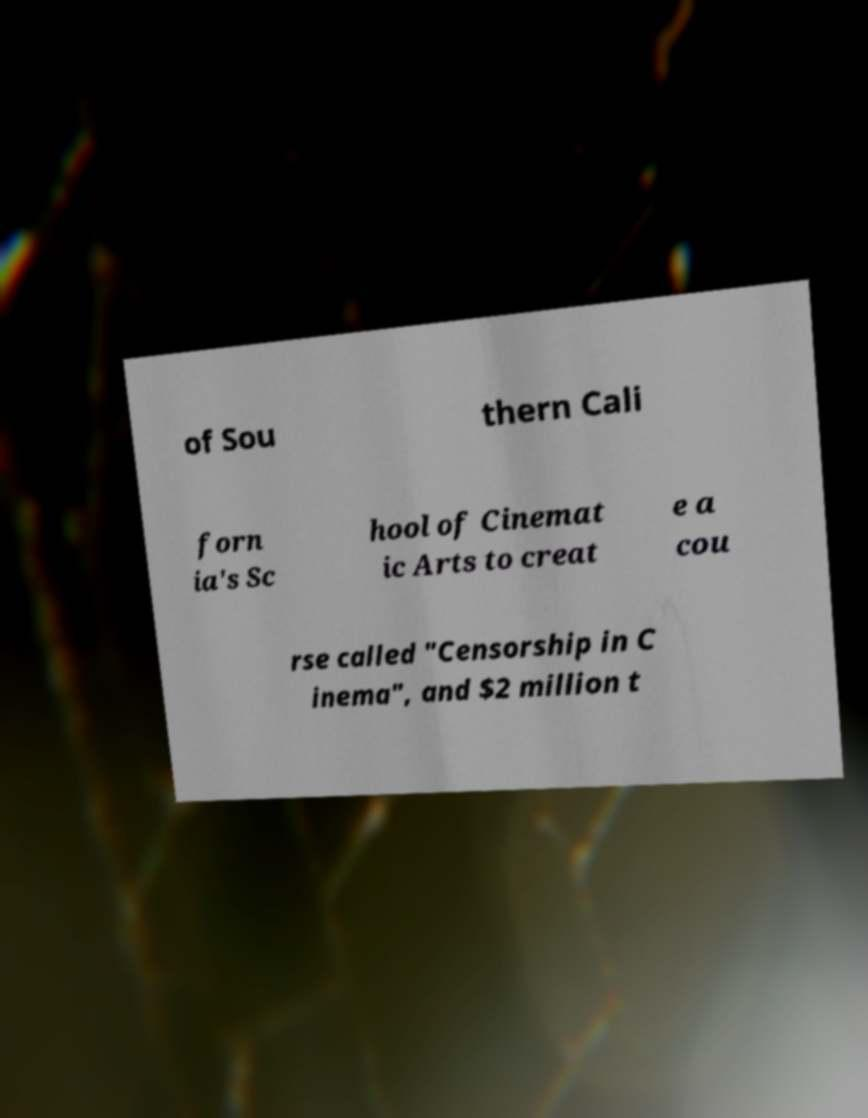Could you assist in decoding the text presented in this image and type it out clearly? of Sou thern Cali forn ia's Sc hool of Cinemat ic Arts to creat e a cou rse called "Censorship in C inema", and $2 million t 